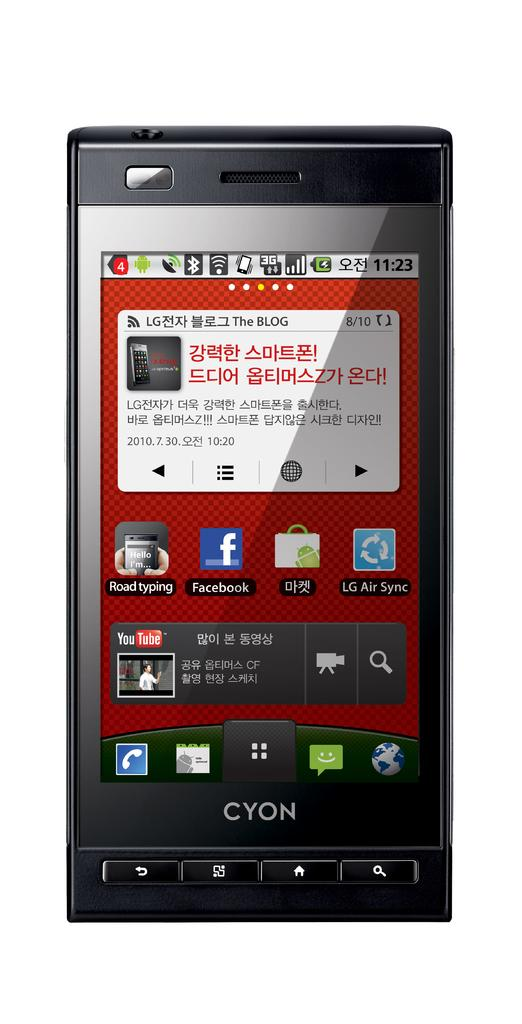<image>
Present a compact description of the photo's key features. A Cyon brand phone has a red background. 